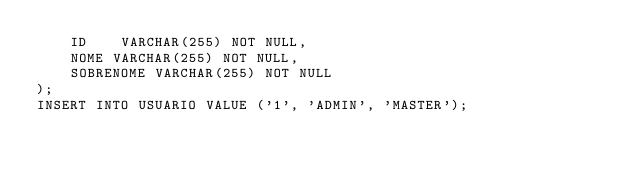Convert code to text. <code><loc_0><loc_0><loc_500><loc_500><_SQL_>    ID    VARCHAR(255) NOT NULL,
    NOME VARCHAR(255) NOT NULL,
    SOBRENOME VARCHAR(255) NOT NULL
);
INSERT INTO USUARIO VALUE ('1', 'ADMIN', 'MASTER');
</code> 